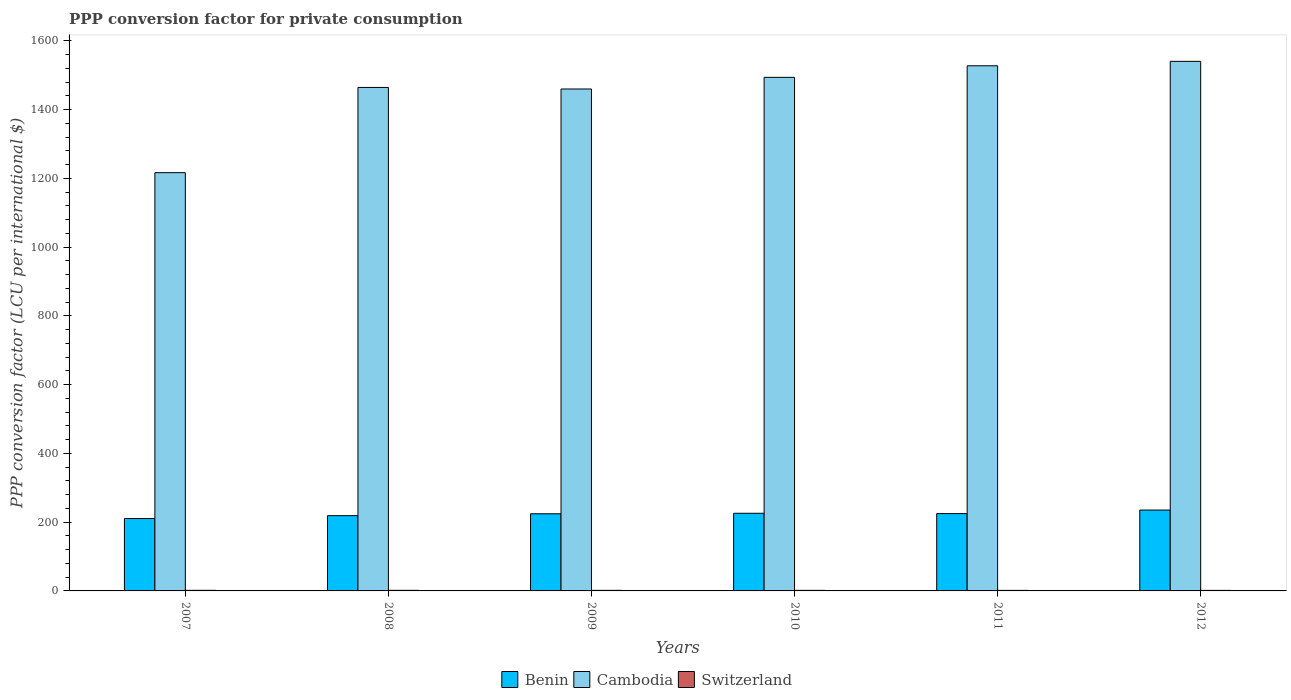How many different coloured bars are there?
Keep it short and to the point. 3. How many groups of bars are there?
Your answer should be compact. 6. What is the label of the 6th group of bars from the left?
Provide a succinct answer. 2012. In how many cases, is the number of bars for a given year not equal to the number of legend labels?
Your answer should be compact. 0. What is the PPP conversion factor for private consumption in Cambodia in 2008?
Offer a very short reply. 1464.58. Across all years, what is the maximum PPP conversion factor for private consumption in Benin?
Your response must be concise. 235.24. Across all years, what is the minimum PPP conversion factor for private consumption in Benin?
Make the answer very short. 210.57. In which year was the PPP conversion factor for private consumption in Cambodia maximum?
Give a very brief answer. 2012. In which year was the PPP conversion factor for private consumption in Switzerland minimum?
Your response must be concise. 2012. What is the total PPP conversion factor for private consumption in Cambodia in the graph?
Your response must be concise. 8703.31. What is the difference between the PPP conversion factor for private consumption in Cambodia in 2007 and that in 2010?
Keep it short and to the point. -277.26. What is the difference between the PPP conversion factor for private consumption in Benin in 2008 and the PPP conversion factor for private consumption in Cambodia in 2011?
Provide a short and direct response. -1308.66. What is the average PPP conversion factor for private consumption in Benin per year?
Provide a short and direct response. 223.32. In the year 2007, what is the difference between the PPP conversion factor for private consumption in Switzerland and PPP conversion factor for private consumption in Cambodia?
Your response must be concise. -1214.91. In how many years, is the PPP conversion factor for private consumption in Cambodia greater than 560 LCU?
Make the answer very short. 6. What is the ratio of the PPP conversion factor for private consumption in Switzerland in 2009 to that in 2012?
Give a very brief answer. 1.07. Is the PPP conversion factor for private consumption in Benin in 2007 less than that in 2012?
Provide a succinct answer. Yes. Is the difference between the PPP conversion factor for private consumption in Switzerland in 2008 and 2010 greater than the difference between the PPP conversion factor for private consumption in Cambodia in 2008 and 2010?
Keep it short and to the point. Yes. What is the difference between the highest and the second highest PPP conversion factor for private consumption in Benin?
Your answer should be very brief. 9.35. What is the difference between the highest and the lowest PPP conversion factor for private consumption in Cambodia?
Provide a succinct answer. 323.81. In how many years, is the PPP conversion factor for private consumption in Benin greater than the average PPP conversion factor for private consumption in Benin taken over all years?
Offer a very short reply. 4. What does the 2nd bar from the left in 2009 represents?
Offer a terse response. Cambodia. What does the 2nd bar from the right in 2011 represents?
Keep it short and to the point. Cambodia. How many bars are there?
Your response must be concise. 18. Are all the bars in the graph horizontal?
Offer a very short reply. No. Are the values on the major ticks of Y-axis written in scientific E-notation?
Give a very brief answer. No. How are the legend labels stacked?
Offer a terse response. Horizontal. What is the title of the graph?
Ensure brevity in your answer.  PPP conversion factor for private consumption. What is the label or title of the Y-axis?
Provide a succinct answer. PPP conversion factor (LCU per international $). What is the PPP conversion factor (LCU per international $) in Benin in 2007?
Offer a terse response. 210.57. What is the PPP conversion factor (LCU per international $) in Cambodia in 2007?
Keep it short and to the point. 1216.67. What is the PPP conversion factor (LCU per international $) of Switzerland in 2007?
Make the answer very short. 1.77. What is the PPP conversion factor (LCU per international $) in Benin in 2008?
Offer a terse response. 218.9. What is the PPP conversion factor (LCU per international $) in Cambodia in 2008?
Your answer should be compact. 1464.58. What is the PPP conversion factor (LCU per international $) in Switzerland in 2008?
Your answer should be very brief. 1.7. What is the PPP conversion factor (LCU per international $) in Benin in 2009?
Provide a short and direct response. 224.42. What is the PPP conversion factor (LCU per international $) of Cambodia in 2009?
Your answer should be very brief. 1460.09. What is the PPP conversion factor (LCU per international $) in Switzerland in 2009?
Offer a very short reply. 1.67. What is the PPP conversion factor (LCU per international $) in Benin in 2010?
Provide a short and direct response. 225.89. What is the PPP conversion factor (LCU per international $) of Cambodia in 2010?
Your response must be concise. 1493.93. What is the PPP conversion factor (LCU per international $) in Switzerland in 2010?
Ensure brevity in your answer.  1.66. What is the PPP conversion factor (LCU per international $) in Benin in 2011?
Make the answer very short. 224.92. What is the PPP conversion factor (LCU per international $) of Cambodia in 2011?
Your answer should be very brief. 1527.56. What is the PPP conversion factor (LCU per international $) in Switzerland in 2011?
Make the answer very short. 1.59. What is the PPP conversion factor (LCU per international $) of Benin in 2012?
Make the answer very short. 235.24. What is the PPP conversion factor (LCU per international $) of Cambodia in 2012?
Provide a succinct answer. 1540.48. What is the PPP conversion factor (LCU per international $) in Switzerland in 2012?
Provide a short and direct response. 1.55. Across all years, what is the maximum PPP conversion factor (LCU per international $) of Benin?
Offer a very short reply. 235.24. Across all years, what is the maximum PPP conversion factor (LCU per international $) of Cambodia?
Your answer should be compact. 1540.48. Across all years, what is the maximum PPP conversion factor (LCU per international $) in Switzerland?
Provide a succinct answer. 1.77. Across all years, what is the minimum PPP conversion factor (LCU per international $) of Benin?
Ensure brevity in your answer.  210.57. Across all years, what is the minimum PPP conversion factor (LCU per international $) in Cambodia?
Offer a very short reply. 1216.67. Across all years, what is the minimum PPP conversion factor (LCU per international $) in Switzerland?
Your answer should be very brief. 1.55. What is the total PPP conversion factor (LCU per international $) in Benin in the graph?
Your answer should be compact. 1339.92. What is the total PPP conversion factor (LCU per international $) in Cambodia in the graph?
Provide a short and direct response. 8703.31. What is the total PPP conversion factor (LCU per international $) of Switzerland in the graph?
Your response must be concise. 9.93. What is the difference between the PPP conversion factor (LCU per international $) of Benin in 2007 and that in 2008?
Provide a short and direct response. -8.33. What is the difference between the PPP conversion factor (LCU per international $) in Cambodia in 2007 and that in 2008?
Keep it short and to the point. -247.91. What is the difference between the PPP conversion factor (LCU per international $) of Switzerland in 2007 and that in 2008?
Your answer should be compact. 0.07. What is the difference between the PPP conversion factor (LCU per international $) of Benin in 2007 and that in 2009?
Your answer should be compact. -13.85. What is the difference between the PPP conversion factor (LCU per international $) in Cambodia in 2007 and that in 2009?
Provide a short and direct response. -243.41. What is the difference between the PPP conversion factor (LCU per international $) of Switzerland in 2007 and that in 2009?
Make the answer very short. 0.1. What is the difference between the PPP conversion factor (LCU per international $) of Benin in 2007 and that in 2010?
Provide a short and direct response. -15.32. What is the difference between the PPP conversion factor (LCU per international $) in Cambodia in 2007 and that in 2010?
Your answer should be very brief. -277.26. What is the difference between the PPP conversion factor (LCU per international $) in Switzerland in 2007 and that in 2010?
Offer a very short reply. 0.11. What is the difference between the PPP conversion factor (LCU per international $) in Benin in 2007 and that in 2011?
Provide a short and direct response. -14.35. What is the difference between the PPP conversion factor (LCU per international $) of Cambodia in 2007 and that in 2011?
Offer a very short reply. -310.88. What is the difference between the PPP conversion factor (LCU per international $) of Switzerland in 2007 and that in 2011?
Your response must be concise. 0.18. What is the difference between the PPP conversion factor (LCU per international $) of Benin in 2007 and that in 2012?
Provide a short and direct response. -24.67. What is the difference between the PPP conversion factor (LCU per international $) in Cambodia in 2007 and that in 2012?
Your answer should be very brief. -323.81. What is the difference between the PPP conversion factor (LCU per international $) in Switzerland in 2007 and that in 2012?
Give a very brief answer. 0.21. What is the difference between the PPP conversion factor (LCU per international $) in Benin in 2008 and that in 2009?
Offer a very short reply. -5.52. What is the difference between the PPP conversion factor (LCU per international $) in Cambodia in 2008 and that in 2009?
Your response must be concise. 4.49. What is the difference between the PPP conversion factor (LCU per international $) in Switzerland in 2008 and that in 2009?
Your answer should be very brief. 0.03. What is the difference between the PPP conversion factor (LCU per international $) of Benin in 2008 and that in 2010?
Your answer should be very brief. -6.99. What is the difference between the PPP conversion factor (LCU per international $) of Cambodia in 2008 and that in 2010?
Give a very brief answer. -29.35. What is the difference between the PPP conversion factor (LCU per international $) of Switzerland in 2008 and that in 2010?
Offer a very short reply. 0.04. What is the difference between the PPP conversion factor (LCU per international $) in Benin in 2008 and that in 2011?
Provide a short and direct response. -6.02. What is the difference between the PPP conversion factor (LCU per international $) in Cambodia in 2008 and that in 2011?
Make the answer very short. -62.98. What is the difference between the PPP conversion factor (LCU per international $) in Switzerland in 2008 and that in 2011?
Your answer should be compact. 0.11. What is the difference between the PPP conversion factor (LCU per international $) of Benin in 2008 and that in 2012?
Give a very brief answer. -16.34. What is the difference between the PPP conversion factor (LCU per international $) in Cambodia in 2008 and that in 2012?
Make the answer very short. -75.9. What is the difference between the PPP conversion factor (LCU per international $) of Switzerland in 2008 and that in 2012?
Your response must be concise. 0.14. What is the difference between the PPP conversion factor (LCU per international $) of Benin in 2009 and that in 2010?
Offer a very short reply. -1.47. What is the difference between the PPP conversion factor (LCU per international $) of Cambodia in 2009 and that in 2010?
Make the answer very short. -33.85. What is the difference between the PPP conversion factor (LCU per international $) of Switzerland in 2009 and that in 2010?
Keep it short and to the point. 0.01. What is the difference between the PPP conversion factor (LCU per international $) in Benin in 2009 and that in 2011?
Provide a succinct answer. -0.5. What is the difference between the PPP conversion factor (LCU per international $) of Cambodia in 2009 and that in 2011?
Your answer should be very brief. -67.47. What is the difference between the PPP conversion factor (LCU per international $) of Switzerland in 2009 and that in 2011?
Your response must be concise. 0.08. What is the difference between the PPP conversion factor (LCU per international $) of Benin in 2009 and that in 2012?
Provide a short and direct response. -10.82. What is the difference between the PPP conversion factor (LCU per international $) of Cambodia in 2009 and that in 2012?
Your answer should be compact. -80.39. What is the difference between the PPP conversion factor (LCU per international $) of Switzerland in 2009 and that in 2012?
Offer a very short reply. 0.11. What is the difference between the PPP conversion factor (LCU per international $) in Benin in 2010 and that in 2011?
Your answer should be very brief. 0.97. What is the difference between the PPP conversion factor (LCU per international $) of Cambodia in 2010 and that in 2011?
Your answer should be compact. -33.62. What is the difference between the PPP conversion factor (LCU per international $) of Switzerland in 2010 and that in 2011?
Make the answer very short. 0.07. What is the difference between the PPP conversion factor (LCU per international $) in Benin in 2010 and that in 2012?
Your answer should be very brief. -9.35. What is the difference between the PPP conversion factor (LCU per international $) in Cambodia in 2010 and that in 2012?
Give a very brief answer. -46.55. What is the difference between the PPP conversion factor (LCU per international $) in Switzerland in 2010 and that in 2012?
Provide a succinct answer. 0.11. What is the difference between the PPP conversion factor (LCU per international $) in Benin in 2011 and that in 2012?
Your answer should be compact. -10.32. What is the difference between the PPP conversion factor (LCU per international $) in Cambodia in 2011 and that in 2012?
Offer a terse response. -12.92. What is the difference between the PPP conversion factor (LCU per international $) in Switzerland in 2011 and that in 2012?
Your response must be concise. 0.03. What is the difference between the PPP conversion factor (LCU per international $) in Benin in 2007 and the PPP conversion factor (LCU per international $) in Cambodia in 2008?
Provide a short and direct response. -1254.01. What is the difference between the PPP conversion factor (LCU per international $) of Benin in 2007 and the PPP conversion factor (LCU per international $) of Switzerland in 2008?
Keep it short and to the point. 208.87. What is the difference between the PPP conversion factor (LCU per international $) in Cambodia in 2007 and the PPP conversion factor (LCU per international $) in Switzerland in 2008?
Your answer should be very brief. 1214.98. What is the difference between the PPP conversion factor (LCU per international $) of Benin in 2007 and the PPP conversion factor (LCU per international $) of Cambodia in 2009?
Offer a very short reply. -1249.52. What is the difference between the PPP conversion factor (LCU per international $) of Benin in 2007 and the PPP conversion factor (LCU per international $) of Switzerland in 2009?
Your answer should be very brief. 208.9. What is the difference between the PPP conversion factor (LCU per international $) in Cambodia in 2007 and the PPP conversion factor (LCU per international $) in Switzerland in 2009?
Keep it short and to the point. 1215.01. What is the difference between the PPP conversion factor (LCU per international $) in Benin in 2007 and the PPP conversion factor (LCU per international $) in Cambodia in 2010?
Give a very brief answer. -1283.37. What is the difference between the PPP conversion factor (LCU per international $) of Benin in 2007 and the PPP conversion factor (LCU per international $) of Switzerland in 2010?
Provide a short and direct response. 208.91. What is the difference between the PPP conversion factor (LCU per international $) in Cambodia in 2007 and the PPP conversion factor (LCU per international $) in Switzerland in 2010?
Your response must be concise. 1215.01. What is the difference between the PPP conversion factor (LCU per international $) of Benin in 2007 and the PPP conversion factor (LCU per international $) of Cambodia in 2011?
Ensure brevity in your answer.  -1316.99. What is the difference between the PPP conversion factor (LCU per international $) in Benin in 2007 and the PPP conversion factor (LCU per international $) in Switzerland in 2011?
Provide a short and direct response. 208.98. What is the difference between the PPP conversion factor (LCU per international $) in Cambodia in 2007 and the PPP conversion factor (LCU per international $) in Switzerland in 2011?
Offer a very short reply. 1215.09. What is the difference between the PPP conversion factor (LCU per international $) of Benin in 2007 and the PPP conversion factor (LCU per international $) of Cambodia in 2012?
Your answer should be compact. -1329.91. What is the difference between the PPP conversion factor (LCU per international $) in Benin in 2007 and the PPP conversion factor (LCU per international $) in Switzerland in 2012?
Give a very brief answer. 209.01. What is the difference between the PPP conversion factor (LCU per international $) of Cambodia in 2007 and the PPP conversion factor (LCU per international $) of Switzerland in 2012?
Keep it short and to the point. 1215.12. What is the difference between the PPP conversion factor (LCU per international $) of Benin in 2008 and the PPP conversion factor (LCU per international $) of Cambodia in 2009?
Offer a terse response. -1241.19. What is the difference between the PPP conversion factor (LCU per international $) in Benin in 2008 and the PPP conversion factor (LCU per international $) in Switzerland in 2009?
Provide a short and direct response. 217.23. What is the difference between the PPP conversion factor (LCU per international $) of Cambodia in 2008 and the PPP conversion factor (LCU per international $) of Switzerland in 2009?
Provide a succinct answer. 1462.92. What is the difference between the PPP conversion factor (LCU per international $) of Benin in 2008 and the PPP conversion factor (LCU per international $) of Cambodia in 2010?
Your response must be concise. -1275.04. What is the difference between the PPP conversion factor (LCU per international $) in Benin in 2008 and the PPP conversion factor (LCU per international $) in Switzerland in 2010?
Your answer should be compact. 217.24. What is the difference between the PPP conversion factor (LCU per international $) of Cambodia in 2008 and the PPP conversion factor (LCU per international $) of Switzerland in 2010?
Provide a succinct answer. 1462.92. What is the difference between the PPP conversion factor (LCU per international $) of Benin in 2008 and the PPP conversion factor (LCU per international $) of Cambodia in 2011?
Your answer should be compact. -1308.66. What is the difference between the PPP conversion factor (LCU per international $) of Benin in 2008 and the PPP conversion factor (LCU per international $) of Switzerland in 2011?
Make the answer very short. 217.31. What is the difference between the PPP conversion factor (LCU per international $) in Cambodia in 2008 and the PPP conversion factor (LCU per international $) in Switzerland in 2011?
Make the answer very short. 1462.99. What is the difference between the PPP conversion factor (LCU per international $) in Benin in 2008 and the PPP conversion factor (LCU per international $) in Cambodia in 2012?
Your response must be concise. -1321.58. What is the difference between the PPP conversion factor (LCU per international $) of Benin in 2008 and the PPP conversion factor (LCU per international $) of Switzerland in 2012?
Make the answer very short. 217.34. What is the difference between the PPP conversion factor (LCU per international $) in Cambodia in 2008 and the PPP conversion factor (LCU per international $) in Switzerland in 2012?
Offer a terse response. 1463.03. What is the difference between the PPP conversion factor (LCU per international $) of Benin in 2009 and the PPP conversion factor (LCU per international $) of Cambodia in 2010?
Provide a short and direct response. -1269.52. What is the difference between the PPP conversion factor (LCU per international $) of Benin in 2009 and the PPP conversion factor (LCU per international $) of Switzerland in 2010?
Make the answer very short. 222.76. What is the difference between the PPP conversion factor (LCU per international $) of Cambodia in 2009 and the PPP conversion factor (LCU per international $) of Switzerland in 2010?
Offer a terse response. 1458.43. What is the difference between the PPP conversion factor (LCU per international $) in Benin in 2009 and the PPP conversion factor (LCU per international $) in Cambodia in 2011?
Make the answer very short. -1303.14. What is the difference between the PPP conversion factor (LCU per international $) in Benin in 2009 and the PPP conversion factor (LCU per international $) in Switzerland in 2011?
Keep it short and to the point. 222.83. What is the difference between the PPP conversion factor (LCU per international $) in Cambodia in 2009 and the PPP conversion factor (LCU per international $) in Switzerland in 2011?
Offer a very short reply. 1458.5. What is the difference between the PPP conversion factor (LCU per international $) of Benin in 2009 and the PPP conversion factor (LCU per international $) of Cambodia in 2012?
Your answer should be very brief. -1316.06. What is the difference between the PPP conversion factor (LCU per international $) of Benin in 2009 and the PPP conversion factor (LCU per international $) of Switzerland in 2012?
Provide a succinct answer. 222.86. What is the difference between the PPP conversion factor (LCU per international $) in Cambodia in 2009 and the PPP conversion factor (LCU per international $) in Switzerland in 2012?
Provide a succinct answer. 1458.53. What is the difference between the PPP conversion factor (LCU per international $) in Benin in 2010 and the PPP conversion factor (LCU per international $) in Cambodia in 2011?
Provide a short and direct response. -1301.67. What is the difference between the PPP conversion factor (LCU per international $) of Benin in 2010 and the PPP conversion factor (LCU per international $) of Switzerland in 2011?
Keep it short and to the point. 224.3. What is the difference between the PPP conversion factor (LCU per international $) in Cambodia in 2010 and the PPP conversion factor (LCU per international $) in Switzerland in 2011?
Make the answer very short. 1492.35. What is the difference between the PPP conversion factor (LCU per international $) in Benin in 2010 and the PPP conversion factor (LCU per international $) in Cambodia in 2012?
Provide a short and direct response. -1314.59. What is the difference between the PPP conversion factor (LCU per international $) in Benin in 2010 and the PPP conversion factor (LCU per international $) in Switzerland in 2012?
Your answer should be very brief. 224.34. What is the difference between the PPP conversion factor (LCU per international $) in Cambodia in 2010 and the PPP conversion factor (LCU per international $) in Switzerland in 2012?
Provide a succinct answer. 1492.38. What is the difference between the PPP conversion factor (LCU per international $) in Benin in 2011 and the PPP conversion factor (LCU per international $) in Cambodia in 2012?
Keep it short and to the point. -1315.56. What is the difference between the PPP conversion factor (LCU per international $) in Benin in 2011 and the PPP conversion factor (LCU per international $) in Switzerland in 2012?
Keep it short and to the point. 223.36. What is the difference between the PPP conversion factor (LCU per international $) in Cambodia in 2011 and the PPP conversion factor (LCU per international $) in Switzerland in 2012?
Keep it short and to the point. 1526. What is the average PPP conversion factor (LCU per international $) in Benin per year?
Offer a very short reply. 223.32. What is the average PPP conversion factor (LCU per international $) in Cambodia per year?
Give a very brief answer. 1450.55. What is the average PPP conversion factor (LCU per international $) of Switzerland per year?
Provide a short and direct response. 1.65. In the year 2007, what is the difference between the PPP conversion factor (LCU per international $) in Benin and PPP conversion factor (LCU per international $) in Cambodia?
Your answer should be very brief. -1006.11. In the year 2007, what is the difference between the PPP conversion factor (LCU per international $) in Benin and PPP conversion factor (LCU per international $) in Switzerland?
Ensure brevity in your answer.  208.8. In the year 2007, what is the difference between the PPP conversion factor (LCU per international $) of Cambodia and PPP conversion factor (LCU per international $) of Switzerland?
Keep it short and to the point. 1214.91. In the year 2008, what is the difference between the PPP conversion factor (LCU per international $) of Benin and PPP conversion factor (LCU per international $) of Cambodia?
Offer a very short reply. -1245.68. In the year 2008, what is the difference between the PPP conversion factor (LCU per international $) in Benin and PPP conversion factor (LCU per international $) in Switzerland?
Ensure brevity in your answer.  217.2. In the year 2008, what is the difference between the PPP conversion factor (LCU per international $) of Cambodia and PPP conversion factor (LCU per international $) of Switzerland?
Keep it short and to the point. 1462.89. In the year 2009, what is the difference between the PPP conversion factor (LCU per international $) of Benin and PPP conversion factor (LCU per international $) of Cambodia?
Offer a terse response. -1235.67. In the year 2009, what is the difference between the PPP conversion factor (LCU per international $) in Benin and PPP conversion factor (LCU per international $) in Switzerland?
Provide a short and direct response. 222.75. In the year 2009, what is the difference between the PPP conversion factor (LCU per international $) in Cambodia and PPP conversion factor (LCU per international $) in Switzerland?
Keep it short and to the point. 1458.42. In the year 2010, what is the difference between the PPP conversion factor (LCU per international $) of Benin and PPP conversion factor (LCU per international $) of Cambodia?
Offer a terse response. -1268.04. In the year 2010, what is the difference between the PPP conversion factor (LCU per international $) in Benin and PPP conversion factor (LCU per international $) in Switzerland?
Give a very brief answer. 224.23. In the year 2010, what is the difference between the PPP conversion factor (LCU per international $) in Cambodia and PPP conversion factor (LCU per international $) in Switzerland?
Your answer should be compact. 1492.28. In the year 2011, what is the difference between the PPP conversion factor (LCU per international $) in Benin and PPP conversion factor (LCU per international $) in Cambodia?
Make the answer very short. -1302.64. In the year 2011, what is the difference between the PPP conversion factor (LCU per international $) of Benin and PPP conversion factor (LCU per international $) of Switzerland?
Your answer should be very brief. 223.33. In the year 2011, what is the difference between the PPP conversion factor (LCU per international $) in Cambodia and PPP conversion factor (LCU per international $) in Switzerland?
Provide a succinct answer. 1525.97. In the year 2012, what is the difference between the PPP conversion factor (LCU per international $) of Benin and PPP conversion factor (LCU per international $) of Cambodia?
Your response must be concise. -1305.24. In the year 2012, what is the difference between the PPP conversion factor (LCU per international $) in Benin and PPP conversion factor (LCU per international $) in Switzerland?
Your answer should be compact. 233.69. In the year 2012, what is the difference between the PPP conversion factor (LCU per international $) in Cambodia and PPP conversion factor (LCU per international $) in Switzerland?
Your answer should be compact. 1538.93. What is the ratio of the PPP conversion factor (LCU per international $) in Benin in 2007 to that in 2008?
Your response must be concise. 0.96. What is the ratio of the PPP conversion factor (LCU per international $) in Cambodia in 2007 to that in 2008?
Make the answer very short. 0.83. What is the ratio of the PPP conversion factor (LCU per international $) in Switzerland in 2007 to that in 2008?
Your response must be concise. 1.04. What is the ratio of the PPP conversion factor (LCU per international $) in Benin in 2007 to that in 2009?
Provide a short and direct response. 0.94. What is the ratio of the PPP conversion factor (LCU per international $) in Cambodia in 2007 to that in 2009?
Offer a very short reply. 0.83. What is the ratio of the PPP conversion factor (LCU per international $) of Switzerland in 2007 to that in 2009?
Your answer should be compact. 1.06. What is the ratio of the PPP conversion factor (LCU per international $) of Benin in 2007 to that in 2010?
Give a very brief answer. 0.93. What is the ratio of the PPP conversion factor (LCU per international $) of Cambodia in 2007 to that in 2010?
Keep it short and to the point. 0.81. What is the ratio of the PPP conversion factor (LCU per international $) in Switzerland in 2007 to that in 2010?
Offer a terse response. 1.06. What is the ratio of the PPP conversion factor (LCU per international $) of Benin in 2007 to that in 2011?
Provide a short and direct response. 0.94. What is the ratio of the PPP conversion factor (LCU per international $) of Cambodia in 2007 to that in 2011?
Offer a terse response. 0.8. What is the ratio of the PPP conversion factor (LCU per international $) of Switzerland in 2007 to that in 2011?
Make the answer very short. 1.11. What is the ratio of the PPP conversion factor (LCU per international $) of Benin in 2007 to that in 2012?
Provide a succinct answer. 0.9. What is the ratio of the PPP conversion factor (LCU per international $) in Cambodia in 2007 to that in 2012?
Offer a terse response. 0.79. What is the ratio of the PPP conversion factor (LCU per international $) in Switzerland in 2007 to that in 2012?
Your response must be concise. 1.14. What is the ratio of the PPP conversion factor (LCU per international $) in Benin in 2008 to that in 2009?
Your answer should be compact. 0.98. What is the ratio of the PPP conversion factor (LCU per international $) of Cambodia in 2008 to that in 2009?
Keep it short and to the point. 1. What is the ratio of the PPP conversion factor (LCU per international $) of Switzerland in 2008 to that in 2009?
Provide a short and direct response. 1.02. What is the ratio of the PPP conversion factor (LCU per international $) of Cambodia in 2008 to that in 2010?
Provide a short and direct response. 0.98. What is the ratio of the PPP conversion factor (LCU per international $) in Switzerland in 2008 to that in 2010?
Offer a very short reply. 1.02. What is the ratio of the PPP conversion factor (LCU per international $) of Benin in 2008 to that in 2011?
Ensure brevity in your answer.  0.97. What is the ratio of the PPP conversion factor (LCU per international $) in Cambodia in 2008 to that in 2011?
Your answer should be very brief. 0.96. What is the ratio of the PPP conversion factor (LCU per international $) of Switzerland in 2008 to that in 2011?
Keep it short and to the point. 1.07. What is the ratio of the PPP conversion factor (LCU per international $) in Benin in 2008 to that in 2012?
Your response must be concise. 0.93. What is the ratio of the PPP conversion factor (LCU per international $) of Cambodia in 2008 to that in 2012?
Your answer should be very brief. 0.95. What is the ratio of the PPP conversion factor (LCU per international $) of Switzerland in 2008 to that in 2012?
Your answer should be very brief. 1.09. What is the ratio of the PPP conversion factor (LCU per international $) of Benin in 2009 to that in 2010?
Keep it short and to the point. 0.99. What is the ratio of the PPP conversion factor (LCU per international $) of Cambodia in 2009 to that in 2010?
Keep it short and to the point. 0.98. What is the ratio of the PPP conversion factor (LCU per international $) of Switzerland in 2009 to that in 2010?
Provide a succinct answer. 1. What is the ratio of the PPP conversion factor (LCU per international $) of Cambodia in 2009 to that in 2011?
Provide a succinct answer. 0.96. What is the ratio of the PPP conversion factor (LCU per international $) in Switzerland in 2009 to that in 2011?
Your answer should be compact. 1.05. What is the ratio of the PPP conversion factor (LCU per international $) in Benin in 2009 to that in 2012?
Ensure brevity in your answer.  0.95. What is the ratio of the PPP conversion factor (LCU per international $) of Cambodia in 2009 to that in 2012?
Your answer should be very brief. 0.95. What is the ratio of the PPP conversion factor (LCU per international $) of Switzerland in 2009 to that in 2012?
Ensure brevity in your answer.  1.07. What is the ratio of the PPP conversion factor (LCU per international $) in Benin in 2010 to that in 2011?
Make the answer very short. 1. What is the ratio of the PPP conversion factor (LCU per international $) in Switzerland in 2010 to that in 2011?
Your response must be concise. 1.04. What is the ratio of the PPP conversion factor (LCU per international $) of Benin in 2010 to that in 2012?
Provide a short and direct response. 0.96. What is the ratio of the PPP conversion factor (LCU per international $) of Cambodia in 2010 to that in 2012?
Offer a terse response. 0.97. What is the ratio of the PPP conversion factor (LCU per international $) of Switzerland in 2010 to that in 2012?
Give a very brief answer. 1.07. What is the ratio of the PPP conversion factor (LCU per international $) of Benin in 2011 to that in 2012?
Ensure brevity in your answer.  0.96. What is the ratio of the PPP conversion factor (LCU per international $) of Switzerland in 2011 to that in 2012?
Offer a terse response. 1.02. What is the difference between the highest and the second highest PPP conversion factor (LCU per international $) of Benin?
Make the answer very short. 9.35. What is the difference between the highest and the second highest PPP conversion factor (LCU per international $) of Cambodia?
Provide a succinct answer. 12.92. What is the difference between the highest and the second highest PPP conversion factor (LCU per international $) in Switzerland?
Keep it short and to the point. 0.07. What is the difference between the highest and the lowest PPP conversion factor (LCU per international $) of Benin?
Provide a succinct answer. 24.67. What is the difference between the highest and the lowest PPP conversion factor (LCU per international $) in Cambodia?
Give a very brief answer. 323.81. What is the difference between the highest and the lowest PPP conversion factor (LCU per international $) of Switzerland?
Your answer should be compact. 0.21. 